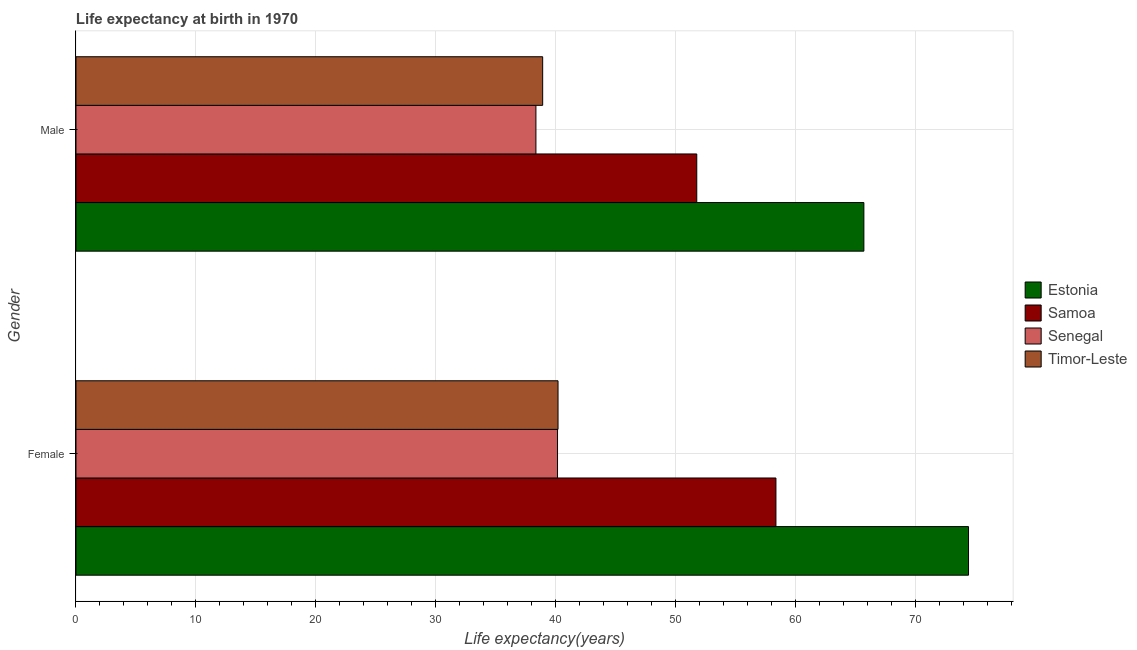How many different coloured bars are there?
Keep it short and to the point. 4. Are the number of bars per tick equal to the number of legend labels?
Your response must be concise. Yes. How many bars are there on the 1st tick from the top?
Give a very brief answer. 4. How many bars are there on the 2nd tick from the bottom?
Offer a very short reply. 4. What is the label of the 2nd group of bars from the top?
Your answer should be very brief. Female. What is the life expectancy(female) in Estonia?
Offer a very short reply. 74.41. Across all countries, what is the maximum life expectancy(male)?
Your answer should be compact. 65.68. Across all countries, what is the minimum life expectancy(female)?
Your answer should be very brief. 40.14. In which country was the life expectancy(female) maximum?
Offer a terse response. Estonia. In which country was the life expectancy(female) minimum?
Ensure brevity in your answer.  Senegal. What is the total life expectancy(male) in the graph?
Provide a short and direct response. 194.68. What is the difference between the life expectancy(female) in Timor-Leste and that in Samoa?
Your answer should be compact. -18.16. What is the difference between the life expectancy(male) in Senegal and the life expectancy(female) in Estonia?
Give a very brief answer. -36.06. What is the average life expectancy(male) per country?
Make the answer very short. 48.67. What is the difference between the life expectancy(male) and life expectancy(female) in Samoa?
Provide a succinct answer. -6.6. In how many countries, is the life expectancy(female) greater than 76 years?
Offer a terse response. 0. What is the ratio of the life expectancy(female) in Timor-Leste to that in Senegal?
Ensure brevity in your answer.  1. In how many countries, is the life expectancy(male) greater than the average life expectancy(male) taken over all countries?
Your response must be concise. 2. What does the 1st bar from the top in Female represents?
Your answer should be compact. Timor-Leste. What does the 4th bar from the bottom in Female represents?
Provide a succinct answer. Timor-Leste. How many bars are there?
Give a very brief answer. 8. Are all the bars in the graph horizontal?
Ensure brevity in your answer.  Yes. How many countries are there in the graph?
Your answer should be very brief. 4. Are the values on the major ticks of X-axis written in scientific E-notation?
Your answer should be very brief. No. Does the graph contain any zero values?
Your response must be concise. No. How many legend labels are there?
Offer a terse response. 4. What is the title of the graph?
Your answer should be compact. Life expectancy at birth in 1970. What is the label or title of the X-axis?
Your answer should be compact. Life expectancy(years). What is the Life expectancy(years) in Estonia in Female?
Ensure brevity in your answer.  74.41. What is the Life expectancy(years) in Samoa in Female?
Your answer should be very brief. 58.35. What is the Life expectancy(years) of Senegal in Female?
Provide a succinct answer. 40.14. What is the Life expectancy(years) of Timor-Leste in Female?
Your answer should be compact. 40.19. What is the Life expectancy(years) of Estonia in Male?
Provide a short and direct response. 65.68. What is the Life expectancy(years) of Samoa in Male?
Your response must be concise. 51.75. What is the Life expectancy(years) in Senegal in Male?
Offer a very short reply. 38.34. What is the Life expectancy(years) of Timor-Leste in Male?
Your response must be concise. 38.9. Across all Gender, what is the maximum Life expectancy(years) in Estonia?
Make the answer very short. 74.41. Across all Gender, what is the maximum Life expectancy(years) of Samoa?
Provide a short and direct response. 58.35. Across all Gender, what is the maximum Life expectancy(years) of Senegal?
Give a very brief answer. 40.14. Across all Gender, what is the maximum Life expectancy(years) of Timor-Leste?
Your answer should be very brief. 40.19. Across all Gender, what is the minimum Life expectancy(years) in Estonia?
Provide a short and direct response. 65.68. Across all Gender, what is the minimum Life expectancy(years) of Samoa?
Offer a very short reply. 51.75. Across all Gender, what is the minimum Life expectancy(years) of Senegal?
Give a very brief answer. 38.34. Across all Gender, what is the minimum Life expectancy(years) in Timor-Leste?
Ensure brevity in your answer.  38.9. What is the total Life expectancy(years) in Estonia in the graph?
Keep it short and to the point. 140.09. What is the total Life expectancy(years) of Samoa in the graph?
Offer a very short reply. 110.1. What is the total Life expectancy(years) of Senegal in the graph?
Ensure brevity in your answer.  78.48. What is the total Life expectancy(years) of Timor-Leste in the graph?
Your answer should be compact. 79.09. What is the difference between the Life expectancy(years) of Estonia in Female and that in Male?
Your answer should be compact. 8.72. What is the difference between the Life expectancy(years) of Samoa in Female and that in Male?
Provide a succinct answer. 6.6. What is the difference between the Life expectancy(years) of Senegal in Female and that in Male?
Ensure brevity in your answer.  1.8. What is the difference between the Life expectancy(years) in Timor-Leste in Female and that in Male?
Your answer should be compact. 1.28. What is the difference between the Life expectancy(years) of Estonia in Female and the Life expectancy(years) of Samoa in Male?
Provide a short and direct response. 22.66. What is the difference between the Life expectancy(years) of Estonia in Female and the Life expectancy(years) of Senegal in Male?
Ensure brevity in your answer.  36.06. What is the difference between the Life expectancy(years) of Estonia in Female and the Life expectancy(years) of Timor-Leste in Male?
Your answer should be very brief. 35.5. What is the difference between the Life expectancy(years) of Samoa in Female and the Life expectancy(years) of Senegal in Male?
Your response must be concise. 20.01. What is the difference between the Life expectancy(years) in Samoa in Female and the Life expectancy(years) in Timor-Leste in Male?
Offer a terse response. 19.45. What is the difference between the Life expectancy(years) in Senegal in Female and the Life expectancy(years) in Timor-Leste in Male?
Your answer should be compact. 1.24. What is the average Life expectancy(years) of Estonia per Gender?
Offer a terse response. 70.04. What is the average Life expectancy(years) of Samoa per Gender?
Ensure brevity in your answer.  55.05. What is the average Life expectancy(years) in Senegal per Gender?
Keep it short and to the point. 39.24. What is the average Life expectancy(years) of Timor-Leste per Gender?
Offer a very short reply. 39.54. What is the difference between the Life expectancy(years) of Estonia and Life expectancy(years) of Samoa in Female?
Offer a very short reply. 16.05. What is the difference between the Life expectancy(years) of Estonia and Life expectancy(years) of Senegal in Female?
Make the answer very short. 34.26. What is the difference between the Life expectancy(years) in Estonia and Life expectancy(years) in Timor-Leste in Female?
Keep it short and to the point. 34.22. What is the difference between the Life expectancy(years) in Samoa and Life expectancy(years) in Senegal in Female?
Provide a short and direct response. 18.21. What is the difference between the Life expectancy(years) in Samoa and Life expectancy(years) in Timor-Leste in Female?
Offer a terse response. 18.16. What is the difference between the Life expectancy(years) of Senegal and Life expectancy(years) of Timor-Leste in Female?
Provide a succinct answer. -0.04. What is the difference between the Life expectancy(years) of Estonia and Life expectancy(years) of Samoa in Male?
Ensure brevity in your answer.  13.93. What is the difference between the Life expectancy(years) of Estonia and Life expectancy(years) of Senegal in Male?
Keep it short and to the point. 27.34. What is the difference between the Life expectancy(years) in Estonia and Life expectancy(years) in Timor-Leste in Male?
Give a very brief answer. 26.78. What is the difference between the Life expectancy(years) of Samoa and Life expectancy(years) of Senegal in Male?
Offer a terse response. 13.41. What is the difference between the Life expectancy(years) of Samoa and Life expectancy(years) of Timor-Leste in Male?
Your response must be concise. 12.85. What is the difference between the Life expectancy(years) in Senegal and Life expectancy(years) in Timor-Leste in Male?
Ensure brevity in your answer.  -0.56. What is the ratio of the Life expectancy(years) in Estonia in Female to that in Male?
Provide a short and direct response. 1.13. What is the ratio of the Life expectancy(years) of Samoa in Female to that in Male?
Your answer should be very brief. 1.13. What is the ratio of the Life expectancy(years) in Senegal in Female to that in Male?
Keep it short and to the point. 1.05. What is the ratio of the Life expectancy(years) of Timor-Leste in Female to that in Male?
Give a very brief answer. 1.03. What is the difference between the highest and the second highest Life expectancy(years) of Estonia?
Offer a terse response. 8.72. What is the difference between the highest and the second highest Life expectancy(years) of Senegal?
Ensure brevity in your answer.  1.8. What is the difference between the highest and the second highest Life expectancy(years) in Timor-Leste?
Your answer should be compact. 1.28. What is the difference between the highest and the lowest Life expectancy(years) of Estonia?
Give a very brief answer. 8.72. What is the difference between the highest and the lowest Life expectancy(years) of Samoa?
Ensure brevity in your answer.  6.6. What is the difference between the highest and the lowest Life expectancy(years) of Senegal?
Your response must be concise. 1.8. What is the difference between the highest and the lowest Life expectancy(years) in Timor-Leste?
Offer a very short reply. 1.28. 